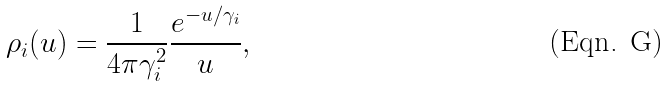<formula> <loc_0><loc_0><loc_500><loc_500>\rho _ { i } ( { u } ) = \frac { 1 } { 4 \pi \gamma _ { i } ^ { 2 } } \frac { e ^ { - u / \gamma _ { i } } } { u } ,</formula> 